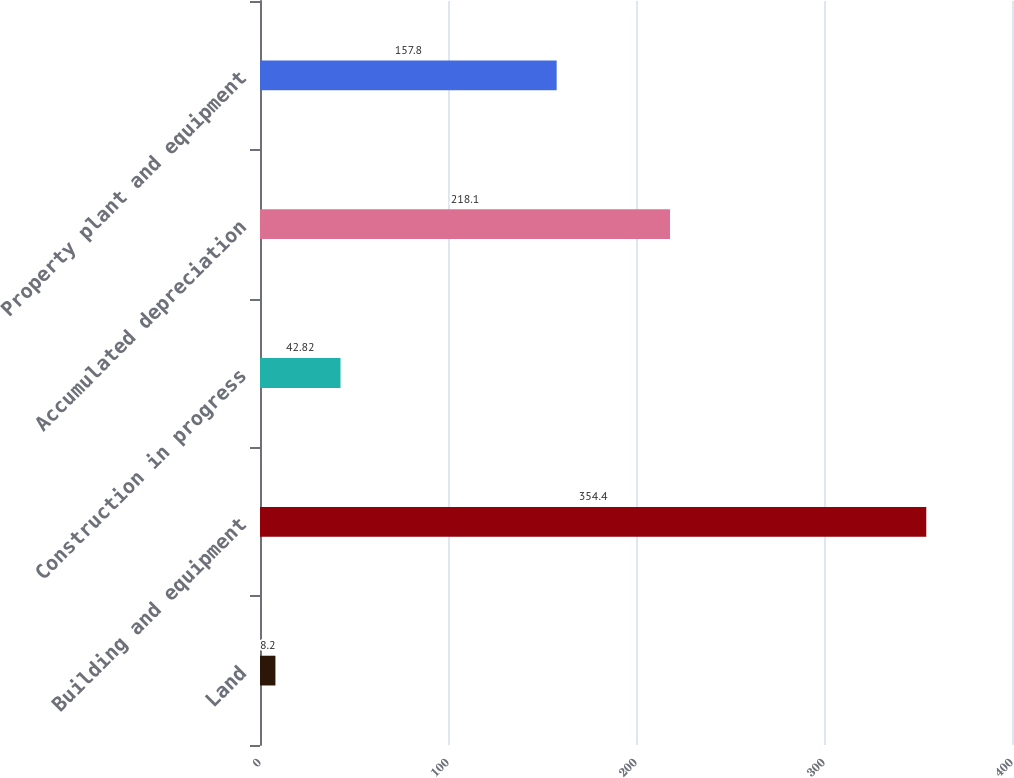Convert chart. <chart><loc_0><loc_0><loc_500><loc_500><bar_chart><fcel>Land<fcel>Building and equipment<fcel>Construction in progress<fcel>Accumulated depreciation<fcel>Property plant and equipment<nl><fcel>8.2<fcel>354.4<fcel>42.82<fcel>218.1<fcel>157.8<nl></chart> 